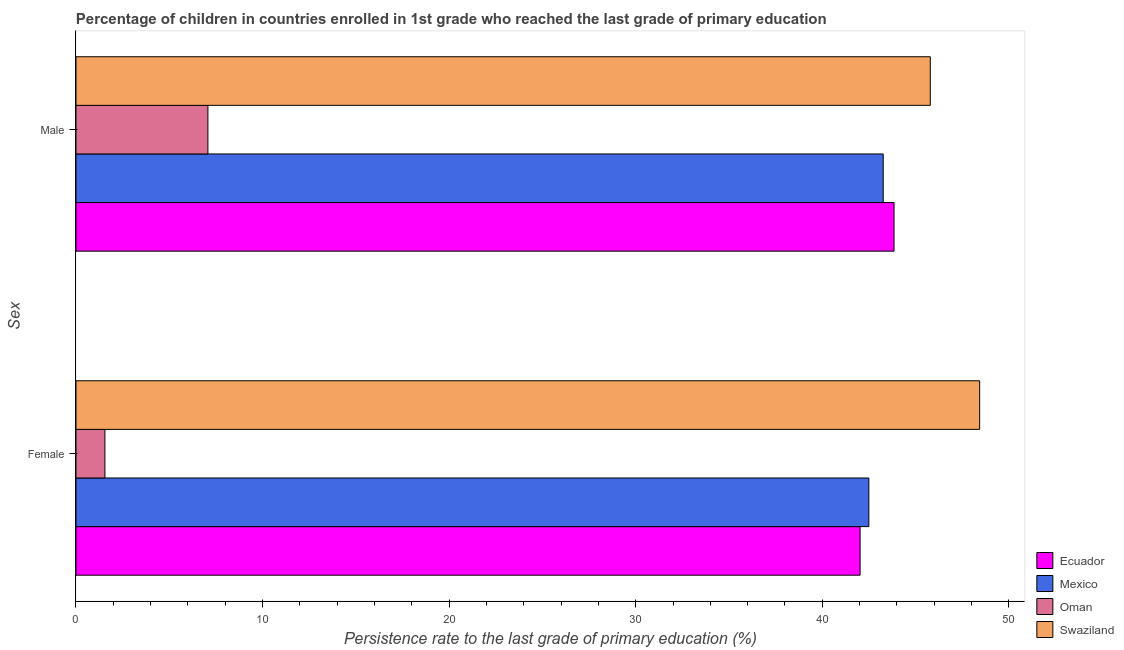How many different coloured bars are there?
Your response must be concise. 4. Are the number of bars per tick equal to the number of legend labels?
Offer a terse response. Yes. Are the number of bars on each tick of the Y-axis equal?
Keep it short and to the point. Yes. How many bars are there on the 1st tick from the top?
Keep it short and to the point. 4. What is the persistence rate of male students in Swaziland?
Your response must be concise. 45.79. Across all countries, what is the maximum persistence rate of male students?
Provide a short and direct response. 45.79. Across all countries, what is the minimum persistence rate of female students?
Make the answer very short. 1.55. In which country was the persistence rate of male students maximum?
Provide a short and direct response. Swaziland. In which country was the persistence rate of female students minimum?
Give a very brief answer. Oman. What is the total persistence rate of female students in the graph?
Make the answer very short. 134.51. What is the difference between the persistence rate of male students in Mexico and that in Swaziland?
Ensure brevity in your answer.  -2.52. What is the difference between the persistence rate of female students in Oman and the persistence rate of male students in Mexico?
Keep it short and to the point. -41.72. What is the average persistence rate of female students per country?
Offer a terse response. 33.63. What is the difference between the persistence rate of female students and persistence rate of male students in Ecuador?
Your answer should be very brief. -1.82. What is the ratio of the persistence rate of female students in Ecuador to that in Swaziland?
Your answer should be very brief. 0.87. What does the 3rd bar from the bottom in Male represents?
Offer a very short reply. Oman. Are all the bars in the graph horizontal?
Offer a very short reply. Yes. Are the values on the major ticks of X-axis written in scientific E-notation?
Keep it short and to the point. No. What is the title of the graph?
Your answer should be very brief. Percentage of children in countries enrolled in 1st grade who reached the last grade of primary education. Does "Austria" appear as one of the legend labels in the graph?
Provide a succinct answer. No. What is the label or title of the X-axis?
Offer a terse response. Persistence rate to the last grade of primary education (%). What is the label or title of the Y-axis?
Your response must be concise. Sex. What is the Persistence rate to the last grade of primary education (%) in Ecuador in Female?
Make the answer very short. 42.03. What is the Persistence rate to the last grade of primary education (%) in Mexico in Female?
Your answer should be very brief. 42.5. What is the Persistence rate to the last grade of primary education (%) in Oman in Female?
Offer a very short reply. 1.55. What is the Persistence rate to the last grade of primary education (%) of Swaziland in Female?
Provide a short and direct response. 48.44. What is the Persistence rate to the last grade of primary education (%) of Ecuador in Male?
Make the answer very short. 43.85. What is the Persistence rate to the last grade of primary education (%) of Mexico in Male?
Your response must be concise. 43.27. What is the Persistence rate to the last grade of primary education (%) of Oman in Male?
Your response must be concise. 7.07. What is the Persistence rate to the last grade of primary education (%) of Swaziland in Male?
Your answer should be compact. 45.79. Across all Sex, what is the maximum Persistence rate to the last grade of primary education (%) of Ecuador?
Ensure brevity in your answer.  43.85. Across all Sex, what is the maximum Persistence rate to the last grade of primary education (%) of Mexico?
Provide a succinct answer. 43.27. Across all Sex, what is the maximum Persistence rate to the last grade of primary education (%) in Oman?
Ensure brevity in your answer.  7.07. Across all Sex, what is the maximum Persistence rate to the last grade of primary education (%) of Swaziland?
Your response must be concise. 48.44. Across all Sex, what is the minimum Persistence rate to the last grade of primary education (%) in Ecuador?
Ensure brevity in your answer.  42.03. Across all Sex, what is the minimum Persistence rate to the last grade of primary education (%) in Mexico?
Offer a terse response. 42.5. Across all Sex, what is the minimum Persistence rate to the last grade of primary education (%) in Oman?
Keep it short and to the point. 1.55. Across all Sex, what is the minimum Persistence rate to the last grade of primary education (%) of Swaziland?
Ensure brevity in your answer.  45.79. What is the total Persistence rate to the last grade of primary education (%) of Ecuador in the graph?
Make the answer very short. 85.88. What is the total Persistence rate to the last grade of primary education (%) in Mexico in the graph?
Ensure brevity in your answer.  85.76. What is the total Persistence rate to the last grade of primary education (%) in Oman in the graph?
Your answer should be compact. 8.62. What is the total Persistence rate to the last grade of primary education (%) of Swaziland in the graph?
Your response must be concise. 94.23. What is the difference between the Persistence rate to the last grade of primary education (%) of Ecuador in Female and that in Male?
Your answer should be compact. -1.82. What is the difference between the Persistence rate to the last grade of primary education (%) of Mexico in Female and that in Male?
Provide a short and direct response. -0.77. What is the difference between the Persistence rate to the last grade of primary education (%) in Oman in Female and that in Male?
Provide a short and direct response. -5.52. What is the difference between the Persistence rate to the last grade of primary education (%) of Swaziland in Female and that in Male?
Your response must be concise. 2.65. What is the difference between the Persistence rate to the last grade of primary education (%) of Ecuador in Female and the Persistence rate to the last grade of primary education (%) of Mexico in Male?
Your answer should be compact. -1.24. What is the difference between the Persistence rate to the last grade of primary education (%) of Ecuador in Female and the Persistence rate to the last grade of primary education (%) of Oman in Male?
Ensure brevity in your answer.  34.96. What is the difference between the Persistence rate to the last grade of primary education (%) of Ecuador in Female and the Persistence rate to the last grade of primary education (%) of Swaziland in Male?
Your answer should be compact. -3.76. What is the difference between the Persistence rate to the last grade of primary education (%) in Mexico in Female and the Persistence rate to the last grade of primary education (%) in Oman in Male?
Your answer should be very brief. 35.43. What is the difference between the Persistence rate to the last grade of primary education (%) of Mexico in Female and the Persistence rate to the last grade of primary education (%) of Swaziland in Male?
Your response must be concise. -3.29. What is the difference between the Persistence rate to the last grade of primary education (%) of Oman in Female and the Persistence rate to the last grade of primary education (%) of Swaziland in Male?
Make the answer very short. -44.24. What is the average Persistence rate to the last grade of primary education (%) in Ecuador per Sex?
Provide a short and direct response. 42.94. What is the average Persistence rate to the last grade of primary education (%) in Mexico per Sex?
Give a very brief answer. 42.88. What is the average Persistence rate to the last grade of primary education (%) in Oman per Sex?
Provide a succinct answer. 4.31. What is the average Persistence rate to the last grade of primary education (%) in Swaziland per Sex?
Provide a short and direct response. 47.11. What is the difference between the Persistence rate to the last grade of primary education (%) of Ecuador and Persistence rate to the last grade of primary education (%) of Mexico in Female?
Your response must be concise. -0.47. What is the difference between the Persistence rate to the last grade of primary education (%) in Ecuador and Persistence rate to the last grade of primary education (%) in Oman in Female?
Ensure brevity in your answer.  40.48. What is the difference between the Persistence rate to the last grade of primary education (%) of Ecuador and Persistence rate to the last grade of primary education (%) of Swaziland in Female?
Keep it short and to the point. -6.41. What is the difference between the Persistence rate to the last grade of primary education (%) of Mexico and Persistence rate to the last grade of primary education (%) of Oman in Female?
Provide a short and direct response. 40.95. What is the difference between the Persistence rate to the last grade of primary education (%) in Mexico and Persistence rate to the last grade of primary education (%) in Swaziland in Female?
Your response must be concise. -5.94. What is the difference between the Persistence rate to the last grade of primary education (%) in Oman and Persistence rate to the last grade of primary education (%) in Swaziland in Female?
Your answer should be compact. -46.89. What is the difference between the Persistence rate to the last grade of primary education (%) of Ecuador and Persistence rate to the last grade of primary education (%) of Mexico in Male?
Ensure brevity in your answer.  0.58. What is the difference between the Persistence rate to the last grade of primary education (%) in Ecuador and Persistence rate to the last grade of primary education (%) in Oman in Male?
Ensure brevity in your answer.  36.78. What is the difference between the Persistence rate to the last grade of primary education (%) in Ecuador and Persistence rate to the last grade of primary education (%) in Swaziland in Male?
Your answer should be compact. -1.94. What is the difference between the Persistence rate to the last grade of primary education (%) in Mexico and Persistence rate to the last grade of primary education (%) in Oman in Male?
Ensure brevity in your answer.  36.2. What is the difference between the Persistence rate to the last grade of primary education (%) of Mexico and Persistence rate to the last grade of primary education (%) of Swaziland in Male?
Give a very brief answer. -2.52. What is the difference between the Persistence rate to the last grade of primary education (%) of Oman and Persistence rate to the last grade of primary education (%) of Swaziland in Male?
Offer a terse response. -38.72. What is the ratio of the Persistence rate to the last grade of primary education (%) of Ecuador in Female to that in Male?
Your answer should be compact. 0.96. What is the ratio of the Persistence rate to the last grade of primary education (%) in Mexico in Female to that in Male?
Your answer should be very brief. 0.98. What is the ratio of the Persistence rate to the last grade of primary education (%) of Oman in Female to that in Male?
Give a very brief answer. 0.22. What is the ratio of the Persistence rate to the last grade of primary education (%) of Swaziland in Female to that in Male?
Offer a terse response. 1.06. What is the difference between the highest and the second highest Persistence rate to the last grade of primary education (%) in Ecuador?
Make the answer very short. 1.82. What is the difference between the highest and the second highest Persistence rate to the last grade of primary education (%) of Mexico?
Your answer should be compact. 0.77. What is the difference between the highest and the second highest Persistence rate to the last grade of primary education (%) in Oman?
Make the answer very short. 5.52. What is the difference between the highest and the second highest Persistence rate to the last grade of primary education (%) in Swaziland?
Offer a terse response. 2.65. What is the difference between the highest and the lowest Persistence rate to the last grade of primary education (%) of Ecuador?
Keep it short and to the point. 1.82. What is the difference between the highest and the lowest Persistence rate to the last grade of primary education (%) in Mexico?
Offer a terse response. 0.77. What is the difference between the highest and the lowest Persistence rate to the last grade of primary education (%) in Oman?
Provide a succinct answer. 5.52. What is the difference between the highest and the lowest Persistence rate to the last grade of primary education (%) of Swaziland?
Offer a terse response. 2.65. 